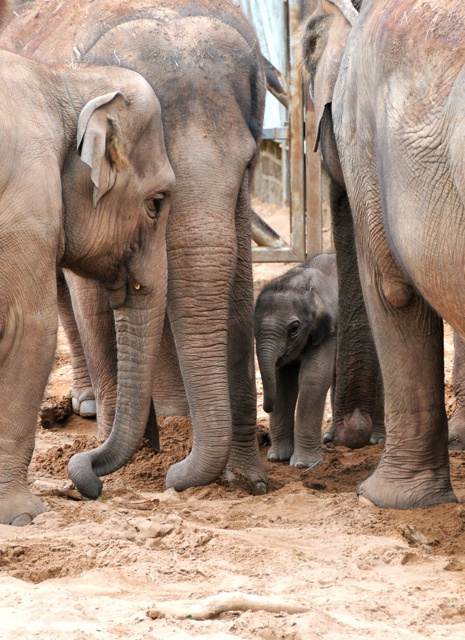Describe the objects in this image and their specific colors. I can see elephant in brown, gray, darkgray, and tan tones, elephant in brown, darkgray, gray, and tan tones, and elephant in brown, black, and gray tones in this image. 